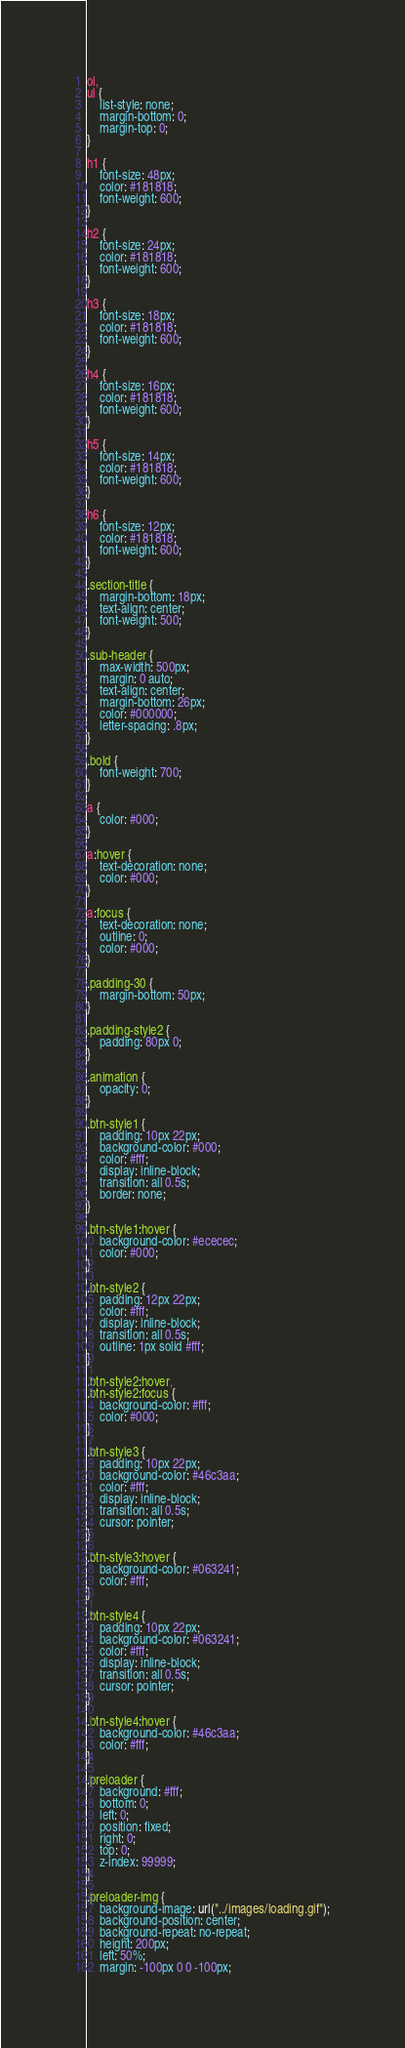Convert code to text. <code><loc_0><loc_0><loc_500><loc_500><_CSS_>
ol,
ul {
    list-style: none;
    margin-bottom: 0;
    margin-top: 0;
}

h1 {
    font-size: 48px;
    color: #181818;
    font-weight: 600;
}

h2 {
    font-size: 24px;
    color: #181818;
    font-weight: 600;
}

h3 {
    font-size: 18px;
    color: #181818;
    font-weight: 600;
}

h4 {
    font-size: 16px;
    color: #181818;
    font-weight: 600;
}

h5 {
    font-size: 14px;
    color: #181818;
    font-weight: 600;
}

h6 {
    font-size: 12px;
    color: #181818;
    font-weight: 600;
}

.section-title {
    margin-bottom: 18px;
    text-align: center;
    font-weight: 500;
}

.sub-header {
    max-width: 500px;
    margin: 0 auto;
    text-align: center;
    margin-bottom: 26px;
    color: #000000;
    letter-spacing: .8px;
}

.bold {
    font-weight: 700;
}

a {
    color: #000;
}

a:hover {
    text-decoration: none;
    color: #000;
}

a:focus {
    text-decoration: none;
    outline: 0;
    color: #000;
}

.padding-30 {
    margin-bottom: 50px;
}

.padding-style2 {
    padding: 80px 0;
}

.animation {
    opacity: 0;
}

.btn-style1 {
    padding: 10px 22px;
    background-color: #000;
    color: #fff;
    display: inline-block;
    transition: all 0.5s;
    border: none;
}

.btn-style1:hover {
    background-color: #ececec;
    color: #000;
}

.btn-style2 {
    padding: 12px 22px;
    color: #fff;
    display: inline-block;
    transition: all 0.5s;
    outline: 1px solid #fff;
}

.btn-style2:hover,
.btn-style2:focus {
    background-color: #fff;
    color: #000;
}

.btn-style3 {
    padding: 10px 22px;
    background-color: #46c3aa;
    color: #fff;
    display: inline-block;
    transition: all 0.5s;
    cursor: pointer;
}

.btn-style3:hover {
    background-color: #063241;
    color: #fff;
}

.btn-style4 {
    padding: 10px 22px;
    background-color: #063241;
    color: #fff;
    display: inline-block;
    transition: all 0.5s;
    cursor: pointer;
}

.btn-style4:hover {
    background-color: #46c3aa;
    color: #fff;
}

.preloader {
    background: #fff;
    bottom: 0;
    left: 0;
    position: fixed;
    right: 0;
    top: 0;
    z-index: 99999;
}

.preloader-img {
    background-image: url("../images/loading.gif");
    background-position: center;
    background-repeat: no-repeat;
    height: 200px;
    left: 50%;
    margin: -100px 0 0 -100px;</code> 